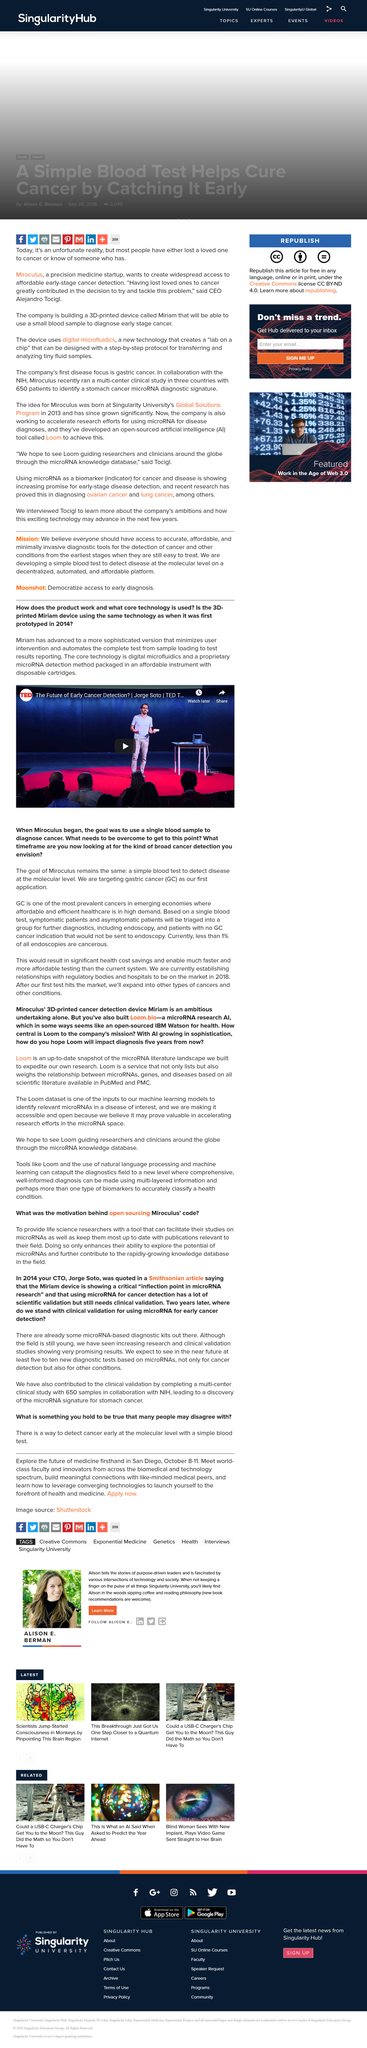Specify some key components in this picture. The video is shareable. Jorge Soto was on TED, and he was successful in presenting his ideas. The goal of using a single blood sample to diagnose cancer was initiated when Miroculus began its operations. PubMed and PMC are two examples of scientific literature that are commonly used in research. Loom is designed to be accessible and open, as evidenced by the fact that it is indeed accessible and open. 